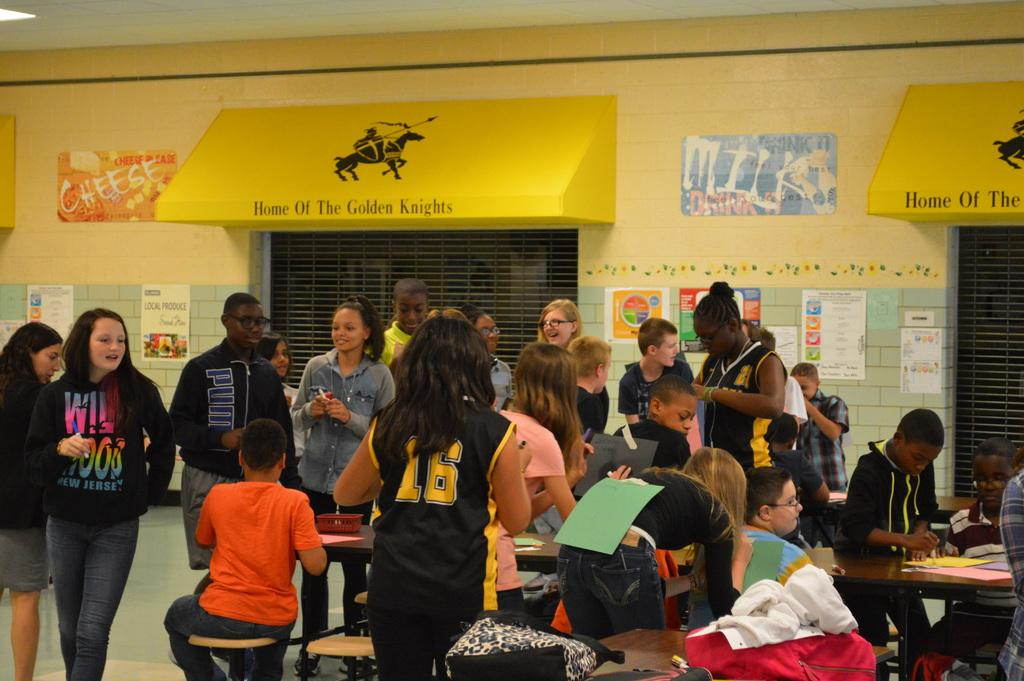How many people are in the image? There are people in the image, but the exact number is not specified. What are some of the people doing in the image? Some people are sitting in the image. What can be found on the tables in the image? There are papers and objects on the tables in the image. What is on the wall in the image? Posters are on the wall in the image. What type of cooking equipment is present in the image? There are grills in the image. What type of sound can be heard coming from the collar in the image? There is no collar present in the image, so it is not possible to determine what type of sound might be heard. 